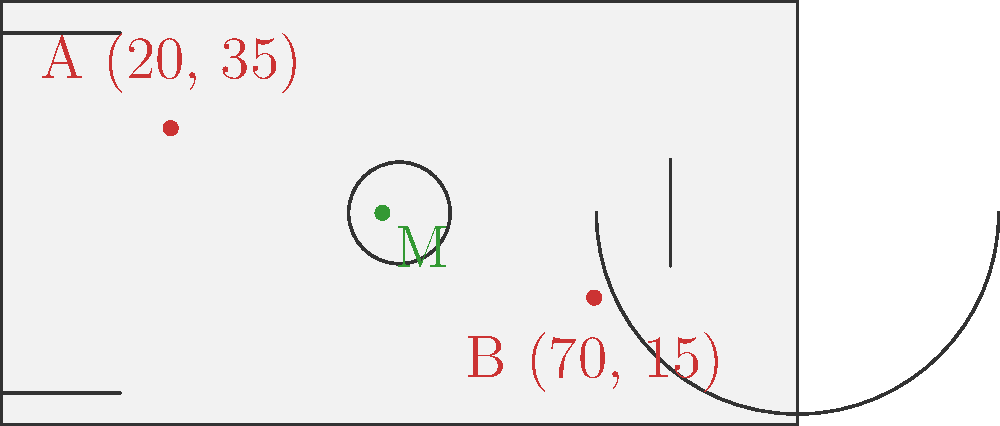In a crucial WNBA game, point guard A is positioned at coordinates (20, 35) on the court, while center B is at (70, 15). The coach wants to determine the optimal passing position M, which is the midpoint between these two players. What are the coordinates of point M? To find the midpoint M between two points A(x₁, y₁) and B(x₂, y₂), we use the midpoint formula:

$$ M_x = \frac{x_1 + x_2}{2}, \quad M_y = \frac{y_1 + y_2}{2} $$

Given:
- Point A: (20, 35)
- Point B: (70, 15)

Step 1: Calculate the x-coordinate of the midpoint:
$$ M_x = \frac{x_1 + x_2}{2} = \frac{20 + 70}{2} = \frac{90}{2} = 45 $$

Step 2: Calculate the y-coordinate of the midpoint:
$$ M_y = \frac{y_1 + y_2}{2} = \frac{35 + 15}{2} = \frac{50}{2} = 25 $$

Therefore, the coordinates of the midpoint M are (45, 25).
Answer: (45, 25) 